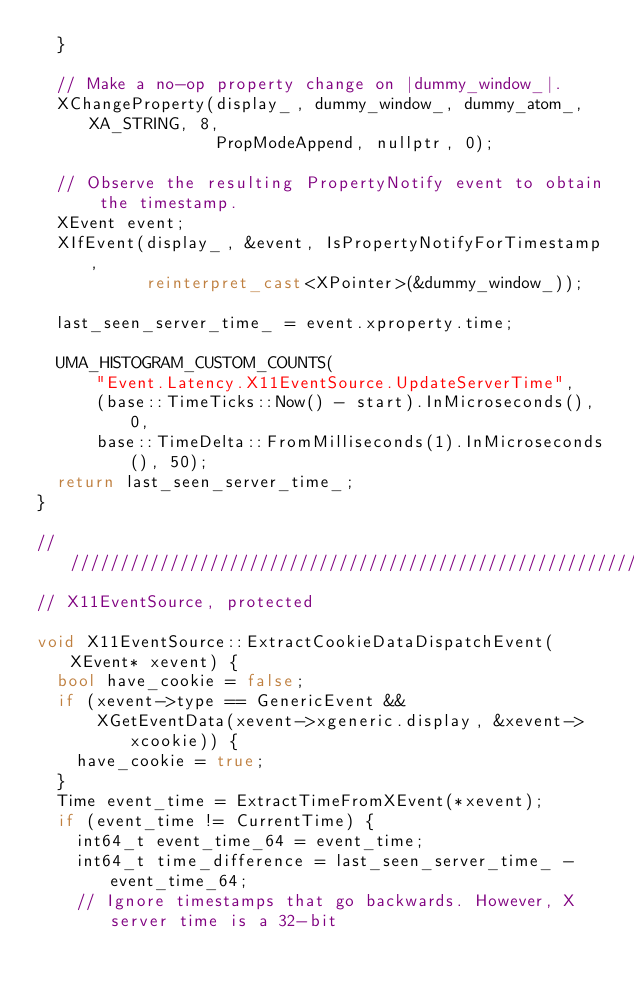<code> <loc_0><loc_0><loc_500><loc_500><_C++_>  }

  // Make a no-op property change on |dummy_window_|.
  XChangeProperty(display_, dummy_window_, dummy_atom_, XA_STRING, 8,
                  PropModeAppend, nullptr, 0);

  // Observe the resulting PropertyNotify event to obtain the timestamp.
  XEvent event;
  XIfEvent(display_, &event, IsPropertyNotifyForTimestamp,
           reinterpret_cast<XPointer>(&dummy_window_));

  last_seen_server_time_ = event.xproperty.time;

  UMA_HISTOGRAM_CUSTOM_COUNTS(
      "Event.Latency.X11EventSource.UpdateServerTime",
      (base::TimeTicks::Now() - start).InMicroseconds(), 0,
      base::TimeDelta::FromMilliseconds(1).InMicroseconds(), 50);
  return last_seen_server_time_;
}

////////////////////////////////////////////////////////////////////////////////
// X11EventSource, protected

void X11EventSource::ExtractCookieDataDispatchEvent(XEvent* xevent) {
  bool have_cookie = false;
  if (xevent->type == GenericEvent &&
      XGetEventData(xevent->xgeneric.display, &xevent->xcookie)) {
    have_cookie = true;
  }
  Time event_time = ExtractTimeFromXEvent(*xevent);
  if (event_time != CurrentTime) {
    int64_t event_time_64 = event_time;
    int64_t time_difference = last_seen_server_time_ - event_time_64;
    // Ignore timestamps that go backwards. However, X server time is a 32-bit</code> 